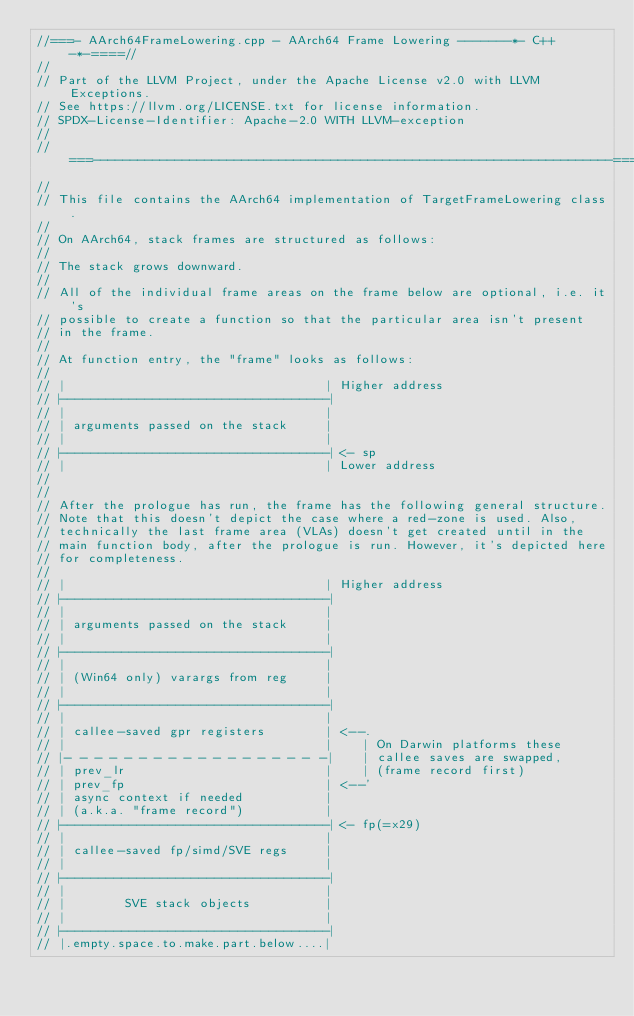<code> <loc_0><loc_0><loc_500><loc_500><_C++_>//===- AArch64FrameLowering.cpp - AArch64 Frame Lowering -------*- C++ -*-====//
//
// Part of the LLVM Project, under the Apache License v2.0 with LLVM Exceptions.
// See https://llvm.org/LICENSE.txt for license information.
// SPDX-License-Identifier: Apache-2.0 WITH LLVM-exception
//
//===----------------------------------------------------------------------===//
//
// This file contains the AArch64 implementation of TargetFrameLowering class.
//
// On AArch64, stack frames are structured as follows:
//
// The stack grows downward.
//
// All of the individual frame areas on the frame below are optional, i.e. it's
// possible to create a function so that the particular area isn't present
// in the frame.
//
// At function entry, the "frame" looks as follows:
//
// |                                   | Higher address
// |-----------------------------------|
// |                                   |
// | arguments passed on the stack     |
// |                                   |
// |-----------------------------------| <- sp
// |                                   | Lower address
//
//
// After the prologue has run, the frame has the following general structure.
// Note that this doesn't depict the case where a red-zone is used. Also,
// technically the last frame area (VLAs) doesn't get created until in the
// main function body, after the prologue is run. However, it's depicted here
// for completeness.
//
// |                                   | Higher address
// |-----------------------------------|
// |                                   |
// | arguments passed on the stack     |
// |                                   |
// |-----------------------------------|
// |                                   |
// | (Win64 only) varargs from reg     |
// |                                   |
// |-----------------------------------|
// |                                   |
// | callee-saved gpr registers        | <--.
// |                                   |    | On Darwin platforms these
// |- - - - - - - - - - - - - - - - - -|    | callee saves are swapped,
// | prev_lr                           |    | (frame record first)
// | prev_fp                           | <--'
// | async context if needed           |
// | (a.k.a. "frame record")           |
// |-----------------------------------| <- fp(=x29)
// |                                   |
// | callee-saved fp/simd/SVE regs     |
// |                                   |
// |-----------------------------------|
// |                                   |
// |        SVE stack objects          |
// |                                   |
// |-----------------------------------|
// |.empty.space.to.make.part.below....|</code> 